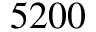<formula> <loc_0><loc_0><loc_500><loc_500>5 2 0 0</formula> 